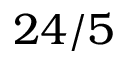Convert formula to latex. <formula><loc_0><loc_0><loc_500><loc_500>2 4 / 5</formula> 